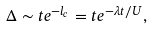<formula> <loc_0><loc_0><loc_500><loc_500>\Delta \sim t e ^ { - l _ { c } } = t e ^ { - \lambda t / U } ,</formula> 